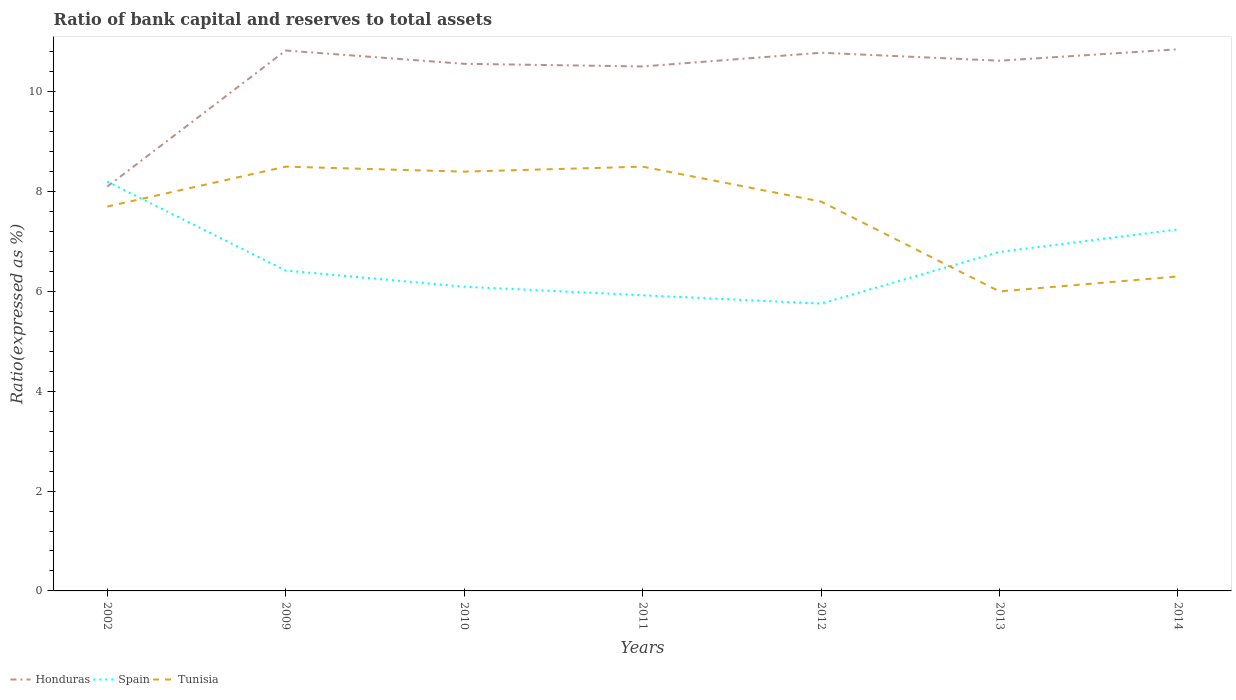Does the line corresponding to Honduras intersect with the line corresponding to Tunisia?
Give a very brief answer. No. Is the number of lines equal to the number of legend labels?
Provide a succinct answer. Yes. Across all years, what is the maximum ratio of bank capital and reserves to total assets in Tunisia?
Your answer should be very brief. 6. In which year was the ratio of bank capital and reserves to total assets in Spain maximum?
Your response must be concise. 2012. What is the total ratio of bank capital and reserves to total assets in Spain in the graph?
Provide a succinct answer. -0.37. Is the ratio of bank capital and reserves to total assets in Spain strictly greater than the ratio of bank capital and reserves to total assets in Tunisia over the years?
Offer a terse response. No. How many lines are there?
Your answer should be compact. 3. How many years are there in the graph?
Give a very brief answer. 7. Where does the legend appear in the graph?
Offer a terse response. Bottom left. How many legend labels are there?
Keep it short and to the point. 3. What is the title of the graph?
Offer a terse response. Ratio of bank capital and reserves to total assets. Does "United Kingdom" appear as one of the legend labels in the graph?
Ensure brevity in your answer.  No. What is the label or title of the Y-axis?
Provide a short and direct response. Ratio(expressed as %). What is the Ratio(expressed as %) of Tunisia in 2002?
Provide a short and direct response. 7.7. What is the Ratio(expressed as %) of Honduras in 2009?
Make the answer very short. 10.83. What is the Ratio(expressed as %) of Spain in 2009?
Ensure brevity in your answer.  6.42. What is the Ratio(expressed as %) of Tunisia in 2009?
Your answer should be very brief. 8.5. What is the Ratio(expressed as %) in Honduras in 2010?
Make the answer very short. 10.56. What is the Ratio(expressed as %) of Spain in 2010?
Provide a succinct answer. 6.09. What is the Ratio(expressed as %) of Tunisia in 2010?
Your response must be concise. 8.4. What is the Ratio(expressed as %) in Honduras in 2011?
Provide a short and direct response. 10.51. What is the Ratio(expressed as %) in Spain in 2011?
Provide a short and direct response. 5.92. What is the Ratio(expressed as %) of Tunisia in 2011?
Your response must be concise. 8.5. What is the Ratio(expressed as %) in Honduras in 2012?
Provide a succinct answer. 10.78. What is the Ratio(expressed as %) in Spain in 2012?
Your answer should be compact. 5.76. What is the Ratio(expressed as %) of Honduras in 2013?
Your response must be concise. 10.62. What is the Ratio(expressed as %) of Spain in 2013?
Keep it short and to the point. 6.79. What is the Ratio(expressed as %) of Honduras in 2014?
Your answer should be very brief. 10.85. What is the Ratio(expressed as %) of Spain in 2014?
Make the answer very short. 7.24. Across all years, what is the maximum Ratio(expressed as %) in Honduras?
Offer a very short reply. 10.85. Across all years, what is the maximum Ratio(expressed as %) of Tunisia?
Offer a terse response. 8.5. Across all years, what is the minimum Ratio(expressed as %) of Honduras?
Make the answer very short. 8.1. Across all years, what is the minimum Ratio(expressed as %) of Spain?
Provide a short and direct response. 5.76. What is the total Ratio(expressed as %) in Honduras in the graph?
Make the answer very short. 72.25. What is the total Ratio(expressed as %) of Spain in the graph?
Provide a succinct answer. 46.43. What is the total Ratio(expressed as %) in Tunisia in the graph?
Provide a succinct answer. 53.2. What is the difference between the Ratio(expressed as %) in Honduras in 2002 and that in 2009?
Offer a very short reply. -2.73. What is the difference between the Ratio(expressed as %) in Spain in 2002 and that in 2009?
Provide a short and direct response. 1.78. What is the difference between the Ratio(expressed as %) in Tunisia in 2002 and that in 2009?
Provide a succinct answer. -0.8. What is the difference between the Ratio(expressed as %) in Honduras in 2002 and that in 2010?
Your answer should be very brief. -2.46. What is the difference between the Ratio(expressed as %) in Spain in 2002 and that in 2010?
Make the answer very short. 2.11. What is the difference between the Ratio(expressed as %) in Honduras in 2002 and that in 2011?
Your answer should be compact. -2.41. What is the difference between the Ratio(expressed as %) in Spain in 2002 and that in 2011?
Make the answer very short. 2.28. What is the difference between the Ratio(expressed as %) in Honduras in 2002 and that in 2012?
Your response must be concise. -2.68. What is the difference between the Ratio(expressed as %) in Spain in 2002 and that in 2012?
Your answer should be very brief. 2.44. What is the difference between the Ratio(expressed as %) of Honduras in 2002 and that in 2013?
Ensure brevity in your answer.  -2.52. What is the difference between the Ratio(expressed as %) in Spain in 2002 and that in 2013?
Provide a succinct answer. 1.41. What is the difference between the Ratio(expressed as %) of Tunisia in 2002 and that in 2013?
Offer a terse response. 1.7. What is the difference between the Ratio(expressed as %) of Honduras in 2002 and that in 2014?
Your answer should be very brief. -2.75. What is the difference between the Ratio(expressed as %) in Spain in 2002 and that in 2014?
Provide a succinct answer. 0.96. What is the difference between the Ratio(expressed as %) in Honduras in 2009 and that in 2010?
Offer a very short reply. 0.27. What is the difference between the Ratio(expressed as %) in Spain in 2009 and that in 2010?
Provide a short and direct response. 0.32. What is the difference between the Ratio(expressed as %) in Honduras in 2009 and that in 2011?
Your answer should be compact. 0.32. What is the difference between the Ratio(expressed as %) in Spain in 2009 and that in 2011?
Your response must be concise. 0.49. What is the difference between the Ratio(expressed as %) in Tunisia in 2009 and that in 2011?
Ensure brevity in your answer.  0. What is the difference between the Ratio(expressed as %) in Honduras in 2009 and that in 2012?
Ensure brevity in your answer.  0.04. What is the difference between the Ratio(expressed as %) of Spain in 2009 and that in 2012?
Offer a very short reply. 0.66. What is the difference between the Ratio(expressed as %) in Tunisia in 2009 and that in 2012?
Your answer should be very brief. 0.7. What is the difference between the Ratio(expressed as %) of Honduras in 2009 and that in 2013?
Provide a succinct answer. 0.2. What is the difference between the Ratio(expressed as %) in Spain in 2009 and that in 2013?
Ensure brevity in your answer.  -0.37. What is the difference between the Ratio(expressed as %) in Tunisia in 2009 and that in 2013?
Offer a very short reply. 2.5. What is the difference between the Ratio(expressed as %) in Honduras in 2009 and that in 2014?
Make the answer very short. -0.02. What is the difference between the Ratio(expressed as %) of Spain in 2009 and that in 2014?
Keep it short and to the point. -0.82. What is the difference between the Ratio(expressed as %) in Honduras in 2010 and that in 2011?
Provide a short and direct response. 0.05. What is the difference between the Ratio(expressed as %) in Spain in 2010 and that in 2011?
Make the answer very short. 0.17. What is the difference between the Ratio(expressed as %) in Honduras in 2010 and that in 2012?
Offer a very short reply. -0.22. What is the difference between the Ratio(expressed as %) of Spain in 2010 and that in 2012?
Offer a terse response. 0.34. What is the difference between the Ratio(expressed as %) in Honduras in 2010 and that in 2013?
Make the answer very short. -0.06. What is the difference between the Ratio(expressed as %) of Spain in 2010 and that in 2013?
Ensure brevity in your answer.  -0.7. What is the difference between the Ratio(expressed as %) of Honduras in 2010 and that in 2014?
Your response must be concise. -0.29. What is the difference between the Ratio(expressed as %) in Spain in 2010 and that in 2014?
Your answer should be very brief. -1.15. What is the difference between the Ratio(expressed as %) of Tunisia in 2010 and that in 2014?
Your answer should be very brief. 2.1. What is the difference between the Ratio(expressed as %) of Honduras in 2011 and that in 2012?
Give a very brief answer. -0.28. What is the difference between the Ratio(expressed as %) of Spain in 2011 and that in 2012?
Your response must be concise. 0.17. What is the difference between the Ratio(expressed as %) of Honduras in 2011 and that in 2013?
Make the answer very short. -0.12. What is the difference between the Ratio(expressed as %) in Spain in 2011 and that in 2013?
Provide a short and direct response. -0.87. What is the difference between the Ratio(expressed as %) of Honduras in 2011 and that in 2014?
Your response must be concise. -0.34. What is the difference between the Ratio(expressed as %) of Spain in 2011 and that in 2014?
Keep it short and to the point. -1.32. What is the difference between the Ratio(expressed as %) of Honduras in 2012 and that in 2013?
Your answer should be compact. 0.16. What is the difference between the Ratio(expressed as %) of Spain in 2012 and that in 2013?
Make the answer very short. -1.04. What is the difference between the Ratio(expressed as %) in Honduras in 2012 and that in 2014?
Provide a short and direct response. -0.07. What is the difference between the Ratio(expressed as %) in Spain in 2012 and that in 2014?
Your answer should be very brief. -1.49. What is the difference between the Ratio(expressed as %) of Tunisia in 2012 and that in 2014?
Give a very brief answer. 1.5. What is the difference between the Ratio(expressed as %) of Honduras in 2013 and that in 2014?
Your response must be concise. -0.23. What is the difference between the Ratio(expressed as %) in Spain in 2013 and that in 2014?
Give a very brief answer. -0.45. What is the difference between the Ratio(expressed as %) of Tunisia in 2013 and that in 2014?
Make the answer very short. -0.3. What is the difference between the Ratio(expressed as %) in Honduras in 2002 and the Ratio(expressed as %) in Spain in 2009?
Your response must be concise. 1.68. What is the difference between the Ratio(expressed as %) of Honduras in 2002 and the Ratio(expressed as %) of Tunisia in 2009?
Make the answer very short. -0.4. What is the difference between the Ratio(expressed as %) of Spain in 2002 and the Ratio(expressed as %) of Tunisia in 2009?
Your response must be concise. -0.3. What is the difference between the Ratio(expressed as %) in Honduras in 2002 and the Ratio(expressed as %) in Spain in 2010?
Make the answer very short. 2.01. What is the difference between the Ratio(expressed as %) in Honduras in 2002 and the Ratio(expressed as %) in Tunisia in 2010?
Ensure brevity in your answer.  -0.3. What is the difference between the Ratio(expressed as %) of Spain in 2002 and the Ratio(expressed as %) of Tunisia in 2010?
Provide a succinct answer. -0.2. What is the difference between the Ratio(expressed as %) in Honduras in 2002 and the Ratio(expressed as %) in Spain in 2011?
Ensure brevity in your answer.  2.18. What is the difference between the Ratio(expressed as %) in Honduras in 2002 and the Ratio(expressed as %) in Tunisia in 2011?
Give a very brief answer. -0.4. What is the difference between the Ratio(expressed as %) in Spain in 2002 and the Ratio(expressed as %) in Tunisia in 2011?
Make the answer very short. -0.3. What is the difference between the Ratio(expressed as %) of Honduras in 2002 and the Ratio(expressed as %) of Spain in 2012?
Your answer should be very brief. 2.34. What is the difference between the Ratio(expressed as %) in Honduras in 2002 and the Ratio(expressed as %) in Spain in 2013?
Provide a short and direct response. 1.31. What is the difference between the Ratio(expressed as %) of Honduras in 2002 and the Ratio(expressed as %) of Tunisia in 2013?
Offer a very short reply. 2.1. What is the difference between the Ratio(expressed as %) in Honduras in 2002 and the Ratio(expressed as %) in Spain in 2014?
Make the answer very short. 0.86. What is the difference between the Ratio(expressed as %) of Honduras in 2002 and the Ratio(expressed as %) of Tunisia in 2014?
Provide a succinct answer. 1.8. What is the difference between the Ratio(expressed as %) in Honduras in 2009 and the Ratio(expressed as %) in Spain in 2010?
Give a very brief answer. 4.73. What is the difference between the Ratio(expressed as %) of Honduras in 2009 and the Ratio(expressed as %) of Tunisia in 2010?
Offer a very short reply. 2.43. What is the difference between the Ratio(expressed as %) of Spain in 2009 and the Ratio(expressed as %) of Tunisia in 2010?
Your answer should be very brief. -1.98. What is the difference between the Ratio(expressed as %) of Honduras in 2009 and the Ratio(expressed as %) of Spain in 2011?
Your answer should be very brief. 4.9. What is the difference between the Ratio(expressed as %) in Honduras in 2009 and the Ratio(expressed as %) in Tunisia in 2011?
Offer a very short reply. 2.33. What is the difference between the Ratio(expressed as %) in Spain in 2009 and the Ratio(expressed as %) in Tunisia in 2011?
Your answer should be compact. -2.08. What is the difference between the Ratio(expressed as %) of Honduras in 2009 and the Ratio(expressed as %) of Spain in 2012?
Provide a succinct answer. 5.07. What is the difference between the Ratio(expressed as %) in Honduras in 2009 and the Ratio(expressed as %) in Tunisia in 2012?
Your answer should be very brief. 3.03. What is the difference between the Ratio(expressed as %) in Spain in 2009 and the Ratio(expressed as %) in Tunisia in 2012?
Ensure brevity in your answer.  -1.38. What is the difference between the Ratio(expressed as %) of Honduras in 2009 and the Ratio(expressed as %) of Spain in 2013?
Your answer should be very brief. 4.03. What is the difference between the Ratio(expressed as %) in Honduras in 2009 and the Ratio(expressed as %) in Tunisia in 2013?
Your response must be concise. 4.83. What is the difference between the Ratio(expressed as %) in Spain in 2009 and the Ratio(expressed as %) in Tunisia in 2013?
Your answer should be compact. 0.42. What is the difference between the Ratio(expressed as %) of Honduras in 2009 and the Ratio(expressed as %) of Spain in 2014?
Your response must be concise. 3.58. What is the difference between the Ratio(expressed as %) of Honduras in 2009 and the Ratio(expressed as %) of Tunisia in 2014?
Ensure brevity in your answer.  4.53. What is the difference between the Ratio(expressed as %) in Spain in 2009 and the Ratio(expressed as %) in Tunisia in 2014?
Offer a very short reply. 0.12. What is the difference between the Ratio(expressed as %) in Honduras in 2010 and the Ratio(expressed as %) in Spain in 2011?
Provide a short and direct response. 4.64. What is the difference between the Ratio(expressed as %) in Honduras in 2010 and the Ratio(expressed as %) in Tunisia in 2011?
Your answer should be very brief. 2.06. What is the difference between the Ratio(expressed as %) of Spain in 2010 and the Ratio(expressed as %) of Tunisia in 2011?
Keep it short and to the point. -2.41. What is the difference between the Ratio(expressed as %) in Honduras in 2010 and the Ratio(expressed as %) in Spain in 2012?
Offer a very short reply. 4.8. What is the difference between the Ratio(expressed as %) of Honduras in 2010 and the Ratio(expressed as %) of Tunisia in 2012?
Offer a very short reply. 2.76. What is the difference between the Ratio(expressed as %) in Spain in 2010 and the Ratio(expressed as %) in Tunisia in 2012?
Ensure brevity in your answer.  -1.71. What is the difference between the Ratio(expressed as %) of Honduras in 2010 and the Ratio(expressed as %) of Spain in 2013?
Offer a terse response. 3.77. What is the difference between the Ratio(expressed as %) in Honduras in 2010 and the Ratio(expressed as %) in Tunisia in 2013?
Ensure brevity in your answer.  4.56. What is the difference between the Ratio(expressed as %) in Spain in 2010 and the Ratio(expressed as %) in Tunisia in 2013?
Your response must be concise. 0.09. What is the difference between the Ratio(expressed as %) in Honduras in 2010 and the Ratio(expressed as %) in Spain in 2014?
Ensure brevity in your answer.  3.32. What is the difference between the Ratio(expressed as %) in Honduras in 2010 and the Ratio(expressed as %) in Tunisia in 2014?
Make the answer very short. 4.26. What is the difference between the Ratio(expressed as %) in Spain in 2010 and the Ratio(expressed as %) in Tunisia in 2014?
Provide a succinct answer. -0.21. What is the difference between the Ratio(expressed as %) in Honduras in 2011 and the Ratio(expressed as %) in Spain in 2012?
Provide a succinct answer. 4.75. What is the difference between the Ratio(expressed as %) of Honduras in 2011 and the Ratio(expressed as %) of Tunisia in 2012?
Offer a very short reply. 2.71. What is the difference between the Ratio(expressed as %) of Spain in 2011 and the Ratio(expressed as %) of Tunisia in 2012?
Provide a short and direct response. -1.88. What is the difference between the Ratio(expressed as %) in Honduras in 2011 and the Ratio(expressed as %) in Spain in 2013?
Your answer should be very brief. 3.72. What is the difference between the Ratio(expressed as %) in Honduras in 2011 and the Ratio(expressed as %) in Tunisia in 2013?
Your response must be concise. 4.51. What is the difference between the Ratio(expressed as %) in Spain in 2011 and the Ratio(expressed as %) in Tunisia in 2013?
Your response must be concise. -0.08. What is the difference between the Ratio(expressed as %) in Honduras in 2011 and the Ratio(expressed as %) in Spain in 2014?
Provide a succinct answer. 3.27. What is the difference between the Ratio(expressed as %) of Honduras in 2011 and the Ratio(expressed as %) of Tunisia in 2014?
Ensure brevity in your answer.  4.21. What is the difference between the Ratio(expressed as %) in Spain in 2011 and the Ratio(expressed as %) in Tunisia in 2014?
Your response must be concise. -0.38. What is the difference between the Ratio(expressed as %) in Honduras in 2012 and the Ratio(expressed as %) in Spain in 2013?
Offer a very short reply. 3.99. What is the difference between the Ratio(expressed as %) of Honduras in 2012 and the Ratio(expressed as %) of Tunisia in 2013?
Provide a succinct answer. 4.78. What is the difference between the Ratio(expressed as %) in Spain in 2012 and the Ratio(expressed as %) in Tunisia in 2013?
Your answer should be compact. -0.24. What is the difference between the Ratio(expressed as %) in Honduras in 2012 and the Ratio(expressed as %) in Spain in 2014?
Provide a succinct answer. 3.54. What is the difference between the Ratio(expressed as %) of Honduras in 2012 and the Ratio(expressed as %) of Tunisia in 2014?
Offer a very short reply. 4.48. What is the difference between the Ratio(expressed as %) of Spain in 2012 and the Ratio(expressed as %) of Tunisia in 2014?
Your answer should be compact. -0.54. What is the difference between the Ratio(expressed as %) in Honduras in 2013 and the Ratio(expressed as %) in Spain in 2014?
Keep it short and to the point. 3.38. What is the difference between the Ratio(expressed as %) in Honduras in 2013 and the Ratio(expressed as %) in Tunisia in 2014?
Keep it short and to the point. 4.32. What is the difference between the Ratio(expressed as %) of Spain in 2013 and the Ratio(expressed as %) of Tunisia in 2014?
Offer a terse response. 0.49. What is the average Ratio(expressed as %) of Honduras per year?
Make the answer very short. 10.32. What is the average Ratio(expressed as %) of Spain per year?
Provide a short and direct response. 6.63. What is the average Ratio(expressed as %) of Tunisia per year?
Offer a terse response. 7.6. In the year 2002, what is the difference between the Ratio(expressed as %) of Honduras and Ratio(expressed as %) of Tunisia?
Your answer should be compact. 0.4. In the year 2009, what is the difference between the Ratio(expressed as %) in Honduras and Ratio(expressed as %) in Spain?
Ensure brevity in your answer.  4.41. In the year 2009, what is the difference between the Ratio(expressed as %) of Honduras and Ratio(expressed as %) of Tunisia?
Ensure brevity in your answer.  2.33. In the year 2009, what is the difference between the Ratio(expressed as %) in Spain and Ratio(expressed as %) in Tunisia?
Provide a short and direct response. -2.08. In the year 2010, what is the difference between the Ratio(expressed as %) in Honduras and Ratio(expressed as %) in Spain?
Provide a succinct answer. 4.47. In the year 2010, what is the difference between the Ratio(expressed as %) of Honduras and Ratio(expressed as %) of Tunisia?
Offer a terse response. 2.16. In the year 2010, what is the difference between the Ratio(expressed as %) in Spain and Ratio(expressed as %) in Tunisia?
Your response must be concise. -2.31. In the year 2011, what is the difference between the Ratio(expressed as %) in Honduras and Ratio(expressed as %) in Spain?
Your answer should be very brief. 4.58. In the year 2011, what is the difference between the Ratio(expressed as %) of Honduras and Ratio(expressed as %) of Tunisia?
Provide a short and direct response. 2.01. In the year 2011, what is the difference between the Ratio(expressed as %) in Spain and Ratio(expressed as %) in Tunisia?
Ensure brevity in your answer.  -2.58. In the year 2012, what is the difference between the Ratio(expressed as %) of Honduras and Ratio(expressed as %) of Spain?
Provide a succinct answer. 5.03. In the year 2012, what is the difference between the Ratio(expressed as %) in Honduras and Ratio(expressed as %) in Tunisia?
Provide a succinct answer. 2.98. In the year 2012, what is the difference between the Ratio(expressed as %) in Spain and Ratio(expressed as %) in Tunisia?
Keep it short and to the point. -2.04. In the year 2013, what is the difference between the Ratio(expressed as %) in Honduras and Ratio(expressed as %) in Spain?
Make the answer very short. 3.83. In the year 2013, what is the difference between the Ratio(expressed as %) in Honduras and Ratio(expressed as %) in Tunisia?
Your answer should be compact. 4.62. In the year 2013, what is the difference between the Ratio(expressed as %) of Spain and Ratio(expressed as %) of Tunisia?
Give a very brief answer. 0.79. In the year 2014, what is the difference between the Ratio(expressed as %) in Honduras and Ratio(expressed as %) in Spain?
Your answer should be very brief. 3.61. In the year 2014, what is the difference between the Ratio(expressed as %) of Honduras and Ratio(expressed as %) of Tunisia?
Make the answer very short. 4.55. In the year 2014, what is the difference between the Ratio(expressed as %) of Spain and Ratio(expressed as %) of Tunisia?
Give a very brief answer. 0.94. What is the ratio of the Ratio(expressed as %) of Honduras in 2002 to that in 2009?
Your response must be concise. 0.75. What is the ratio of the Ratio(expressed as %) of Spain in 2002 to that in 2009?
Your response must be concise. 1.28. What is the ratio of the Ratio(expressed as %) in Tunisia in 2002 to that in 2009?
Ensure brevity in your answer.  0.91. What is the ratio of the Ratio(expressed as %) of Honduras in 2002 to that in 2010?
Your answer should be very brief. 0.77. What is the ratio of the Ratio(expressed as %) of Spain in 2002 to that in 2010?
Provide a succinct answer. 1.35. What is the ratio of the Ratio(expressed as %) in Honduras in 2002 to that in 2011?
Your answer should be very brief. 0.77. What is the ratio of the Ratio(expressed as %) in Spain in 2002 to that in 2011?
Provide a succinct answer. 1.38. What is the ratio of the Ratio(expressed as %) in Tunisia in 2002 to that in 2011?
Offer a very short reply. 0.91. What is the ratio of the Ratio(expressed as %) in Honduras in 2002 to that in 2012?
Keep it short and to the point. 0.75. What is the ratio of the Ratio(expressed as %) of Spain in 2002 to that in 2012?
Ensure brevity in your answer.  1.42. What is the ratio of the Ratio(expressed as %) in Tunisia in 2002 to that in 2012?
Provide a short and direct response. 0.99. What is the ratio of the Ratio(expressed as %) in Honduras in 2002 to that in 2013?
Offer a terse response. 0.76. What is the ratio of the Ratio(expressed as %) of Spain in 2002 to that in 2013?
Make the answer very short. 1.21. What is the ratio of the Ratio(expressed as %) of Tunisia in 2002 to that in 2013?
Give a very brief answer. 1.28. What is the ratio of the Ratio(expressed as %) in Honduras in 2002 to that in 2014?
Make the answer very short. 0.75. What is the ratio of the Ratio(expressed as %) in Spain in 2002 to that in 2014?
Your answer should be very brief. 1.13. What is the ratio of the Ratio(expressed as %) in Tunisia in 2002 to that in 2014?
Give a very brief answer. 1.22. What is the ratio of the Ratio(expressed as %) of Honduras in 2009 to that in 2010?
Your answer should be compact. 1.03. What is the ratio of the Ratio(expressed as %) of Spain in 2009 to that in 2010?
Offer a very short reply. 1.05. What is the ratio of the Ratio(expressed as %) in Tunisia in 2009 to that in 2010?
Provide a succinct answer. 1.01. What is the ratio of the Ratio(expressed as %) in Honduras in 2009 to that in 2011?
Make the answer very short. 1.03. What is the ratio of the Ratio(expressed as %) of Spain in 2009 to that in 2011?
Provide a succinct answer. 1.08. What is the ratio of the Ratio(expressed as %) of Tunisia in 2009 to that in 2011?
Give a very brief answer. 1. What is the ratio of the Ratio(expressed as %) in Honduras in 2009 to that in 2012?
Give a very brief answer. 1. What is the ratio of the Ratio(expressed as %) in Spain in 2009 to that in 2012?
Your answer should be very brief. 1.11. What is the ratio of the Ratio(expressed as %) of Tunisia in 2009 to that in 2012?
Your response must be concise. 1.09. What is the ratio of the Ratio(expressed as %) in Honduras in 2009 to that in 2013?
Ensure brevity in your answer.  1.02. What is the ratio of the Ratio(expressed as %) of Spain in 2009 to that in 2013?
Your answer should be very brief. 0.94. What is the ratio of the Ratio(expressed as %) in Tunisia in 2009 to that in 2013?
Offer a terse response. 1.42. What is the ratio of the Ratio(expressed as %) of Spain in 2009 to that in 2014?
Your response must be concise. 0.89. What is the ratio of the Ratio(expressed as %) in Tunisia in 2009 to that in 2014?
Ensure brevity in your answer.  1.35. What is the ratio of the Ratio(expressed as %) in Spain in 2010 to that in 2011?
Offer a very short reply. 1.03. What is the ratio of the Ratio(expressed as %) of Tunisia in 2010 to that in 2011?
Offer a very short reply. 0.99. What is the ratio of the Ratio(expressed as %) of Honduras in 2010 to that in 2012?
Offer a terse response. 0.98. What is the ratio of the Ratio(expressed as %) of Spain in 2010 to that in 2012?
Ensure brevity in your answer.  1.06. What is the ratio of the Ratio(expressed as %) of Spain in 2010 to that in 2013?
Make the answer very short. 0.9. What is the ratio of the Ratio(expressed as %) of Tunisia in 2010 to that in 2013?
Your response must be concise. 1.4. What is the ratio of the Ratio(expressed as %) in Honduras in 2010 to that in 2014?
Offer a terse response. 0.97. What is the ratio of the Ratio(expressed as %) of Spain in 2010 to that in 2014?
Your answer should be very brief. 0.84. What is the ratio of the Ratio(expressed as %) in Honduras in 2011 to that in 2012?
Offer a terse response. 0.97. What is the ratio of the Ratio(expressed as %) of Spain in 2011 to that in 2012?
Provide a short and direct response. 1.03. What is the ratio of the Ratio(expressed as %) of Tunisia in 2011 to that in 2012?
Give a very brief answer. 1.09. What is the ratio of the Ratio(expressed as %) of Spain in 2011 to that in 2013?
Your response must be concise. 0.87. What is the ratio of the Ratio(expressed as %) of Tunisia in 2011 to that in 2013?
Keep it short and to the point. 1.42. What is the ratio of the Ratio(expressed as %) in Honduras in 2011 to that in 2014?
Your answer should be very brief. 0.97. What is the ratio of the Ratio(expressed as %) of Spain in 2011 to that in 2014?
Your response must be concise. 0.82. What is the ratio of the Ratio(expressed as %) in Tunisia in 2011 to that in 2014?
Your answer should be compact. 1.35. What is the ratio of the Ratio(expressed as %) of Spain in 2012 to that in 2013?
Offer a terse response. 0.85. What is the ratio of the Ratio(expressed as %) in Tunisia in 2012 to that in 2013?
Your response must be concise. 1.3. What is the ratio of the Ratio(expressed as %) of Spain in 2012 to that in 2014?
Offer a very short reply. 0.79. What is the ratio of the Ratio(expressed as %) of Tunisia in 2012 to that in 2014?
Offer a terse response. 1.24. What is the ratio of the Ratio(expressed as %) in Honduras in 2013 to that in 2014?
Offer a terse response. 0.98. What is the ratio of the Ratio(expressed as %) in Spain in 2013 to that in 2014?
Give a very brief answer. 0.94. What is the difference between the highest and the second highest Ratio(expressed as %) in Honduras?
Keep it short and to the point. 0.02. What is the difference between the highest and the second highest Ratio(expressed as %) in Spain?
Provide a short and direct response. 0.96. What is the difference between the highest and the second highest Ratio(expressed as %) of Tunisia?
Give a very brief answer. 0. What is the difference between the highest and the lowest Ratio(expressed as %) of Honduras?
Offer a terse response. 2.75. What is the difference between the highest and the lowest Ratio(expressed as %) in Spain?
Your response must be concise. 2.44. 